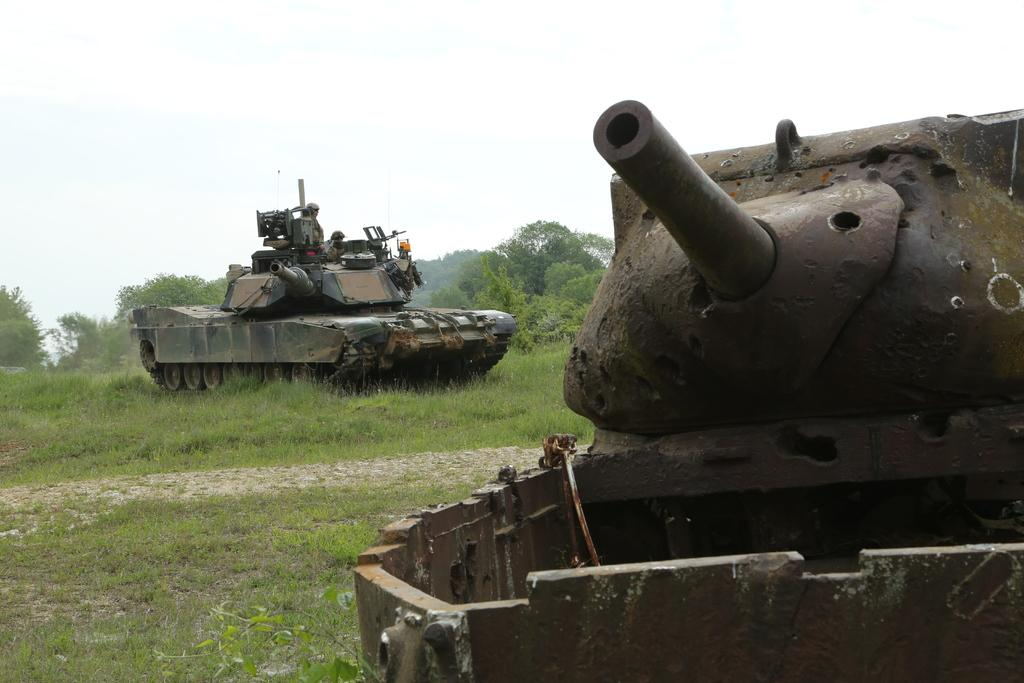What type of vehicles are present in the image? There are army panzers in the image. What is the ground covered with in the image? There is green grass on the ground in the image. What can be seen in the background of the image? There are trees in the background of the image. What type of flag is being waved by the creator in the image? There is no creator or flag present in the image; it features army panzers on green grass with trees in the background. 